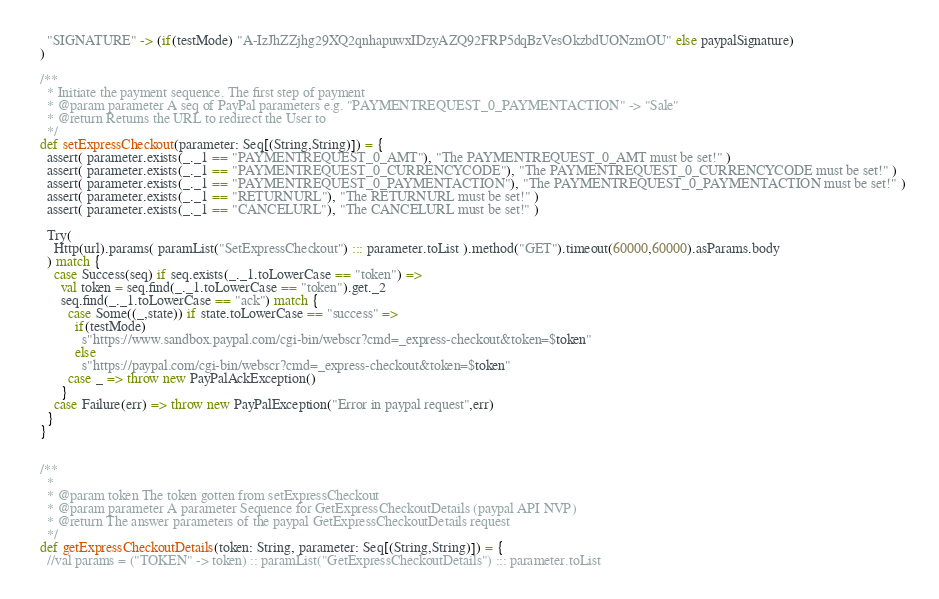Convert code to text. <code><loc_0><loc_0><loc_500><loc_500><_Scala_>    "SIGNATURE" -> (if(testMode) "A-IzJhZZjhg29XQ2qnhapuwxIDzyAZQ92FRP5dqBzVesOkzbdUONzmOU" else paypalSignature)
  )

  /**
    * Initiate the payment sequence. The first step of payment
    * @param parameter A seq of PayPal parameters e.g. "PAYMENTREQUEST_0_PAYMENTACTION" -> "Sale"
    * @return Returns the URL to redirect the User to
    */
  def setExpressCheckout(parameter: Seq[(String,String)]) = {
    assert( parameter.exists(_._1 == "PAYMENTREQUEST_0_AMT"), "The PAYMENTREQUEST_0_AMT must be set!" )
    assert( parameter.exists(_._1 == "PAYMENTREQUEST_0_CURRENCYCODE"), "The PAYMENTREQUEST_0_CURRENCYCODE must be set!" )
    assert( parameter.exists(_._1 == "PAYMENTREQUEST_0_PAYMENTACTION"), "The PAYMENTREQUEST_0_PAYMENTACTION must be set!" )
    assert( parameter.exists(_._1 == "RETURNURL"), "The RETURNURL must be set!" )
    assert( parameter.exists(_._1 == "CANCELURL"), "The CANCELURL must be set!" )

    Try(
      Http(url).params( paramList("SetExpressCheckout") ::: parameter.toList ).method("GET").timeout(60000,60000).asParams.body
    ) match {
      case Success(seq) if seq.exists(_._1.toLowerCase == "token") =>
        val token = seq.find(_._1.toLowerCase == "token").get._2
        seq.find(_._1.toLowerCase == "ack") match {
          case Some((_,state)) if state.toLowerCase == "success" =>
            if(testMode)
              s"https://www.sandbox.paypal.com/cgi-bin/webscr?cmd=_express-checkout&token=$token"
            else
              s"https://paypal.com/cgi-bin/webscr?cmd=_express-checkout&token=$token"
          case _ => throw new PayPalAckException()
        }
      case Failure(err) => throw new PayPalException("Error in paypal request",err)
    }
  }


  /**
    *
    * @param token The token gotten from setExpressCheckout
    * @param parameter A parameter Sequence for GetExpressCheckoutDetails (paypal API NVP)
    * @return The answer parameters of the paypal GetExpressCheckoutDetails request
    */
  def getExpressCheckoutDetails(token: String, parameter: Seq[(String,String)]) = {
    //val params = ("TOKEN" -> token) :: paramList("GetExpressCheckoutDetails") ::: parameter.toList</code> 